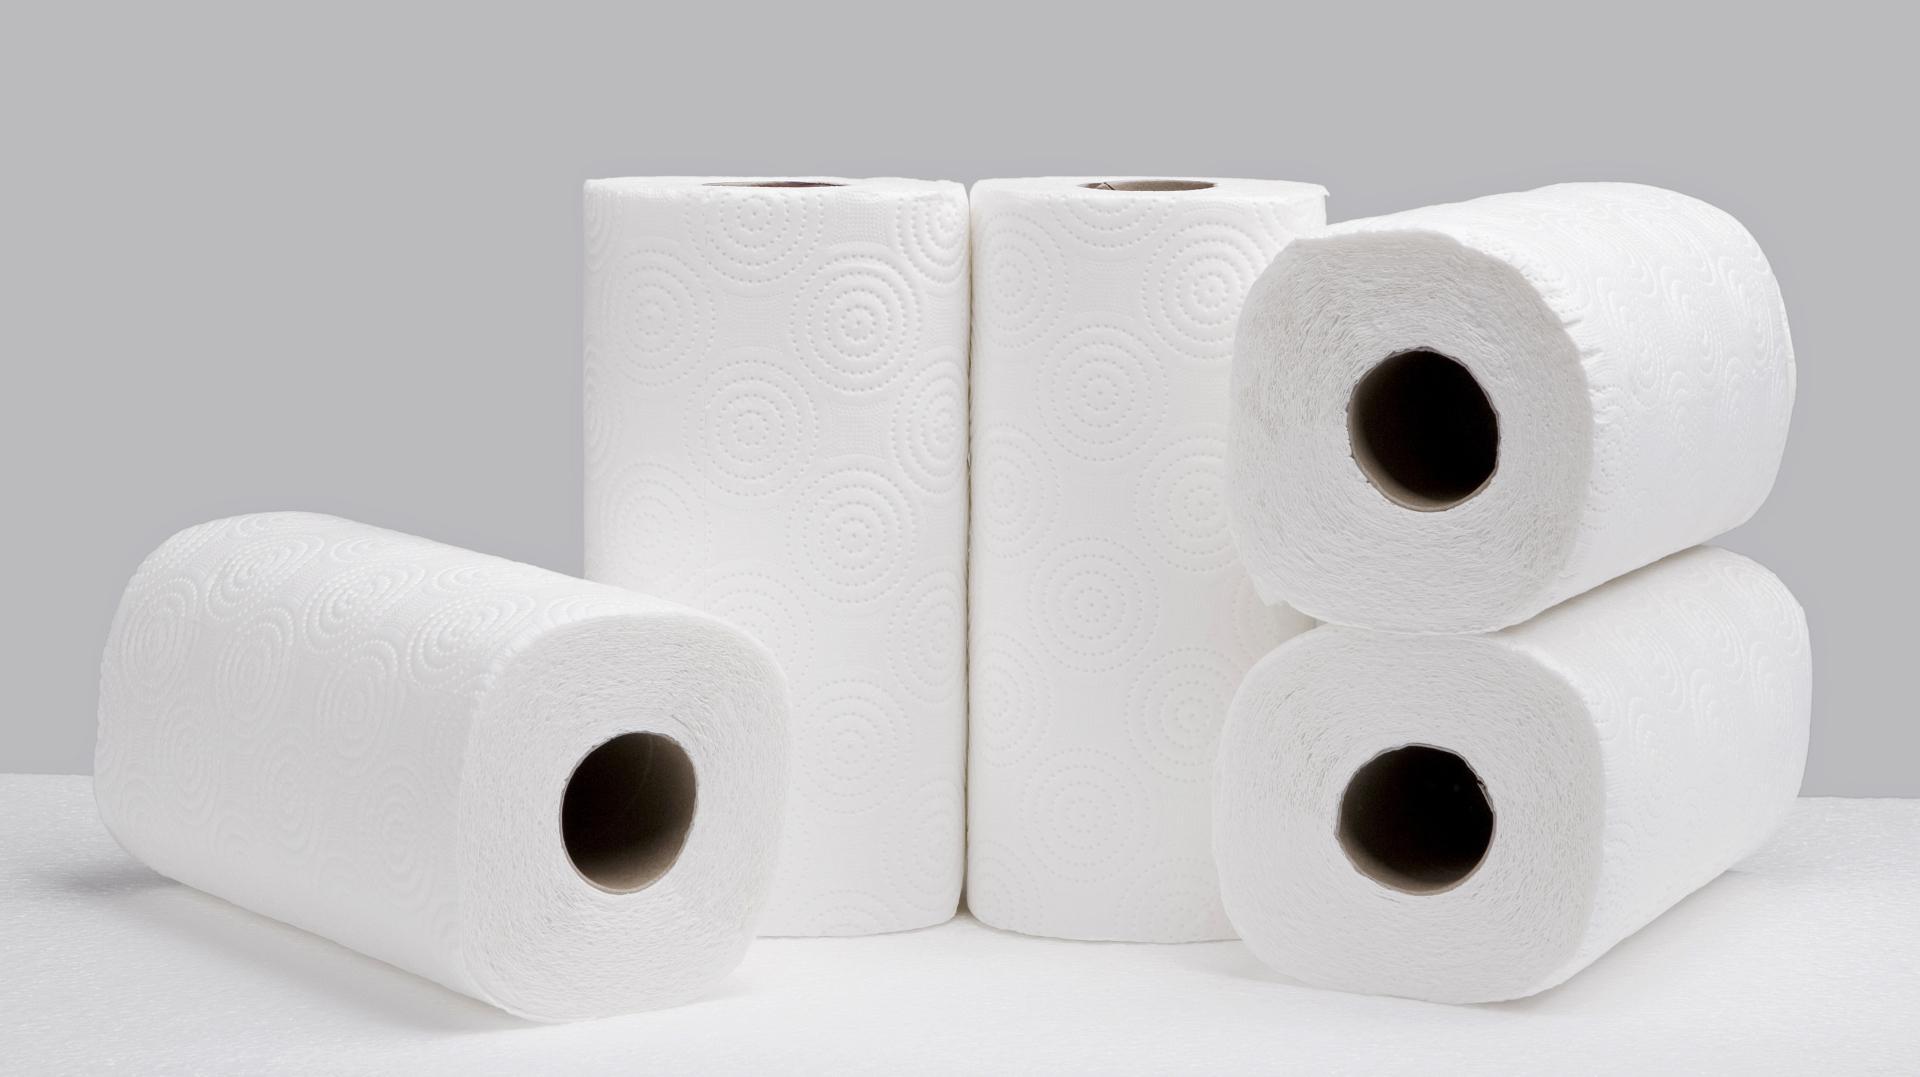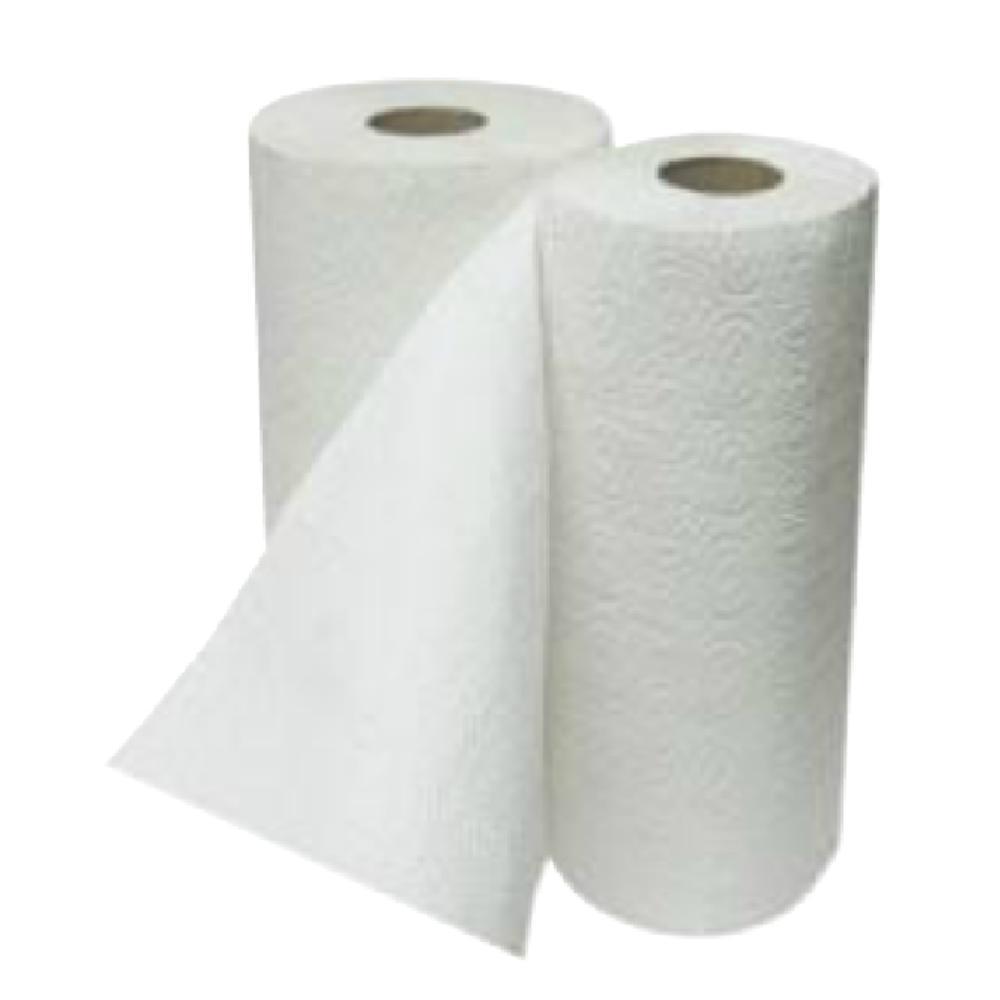The first image is the image on the left, the second image is the image on the right. Considering the images on both sides, is "there are at seven rolls total" valid? Answer yes or no. Yes. 